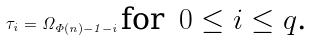Convert formula to latex. <formula><loc_0><loc_0><loc_500><loc_500>\tau _ { i } = \Omega _ { \Phi ( n ) - 1 - i } \, \text {for \,$0 \leq i \leq q$.}</formula> 